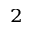<formula> <loc_0><loc_0><loc_500><loc_500>^ { 2 }</formula> 